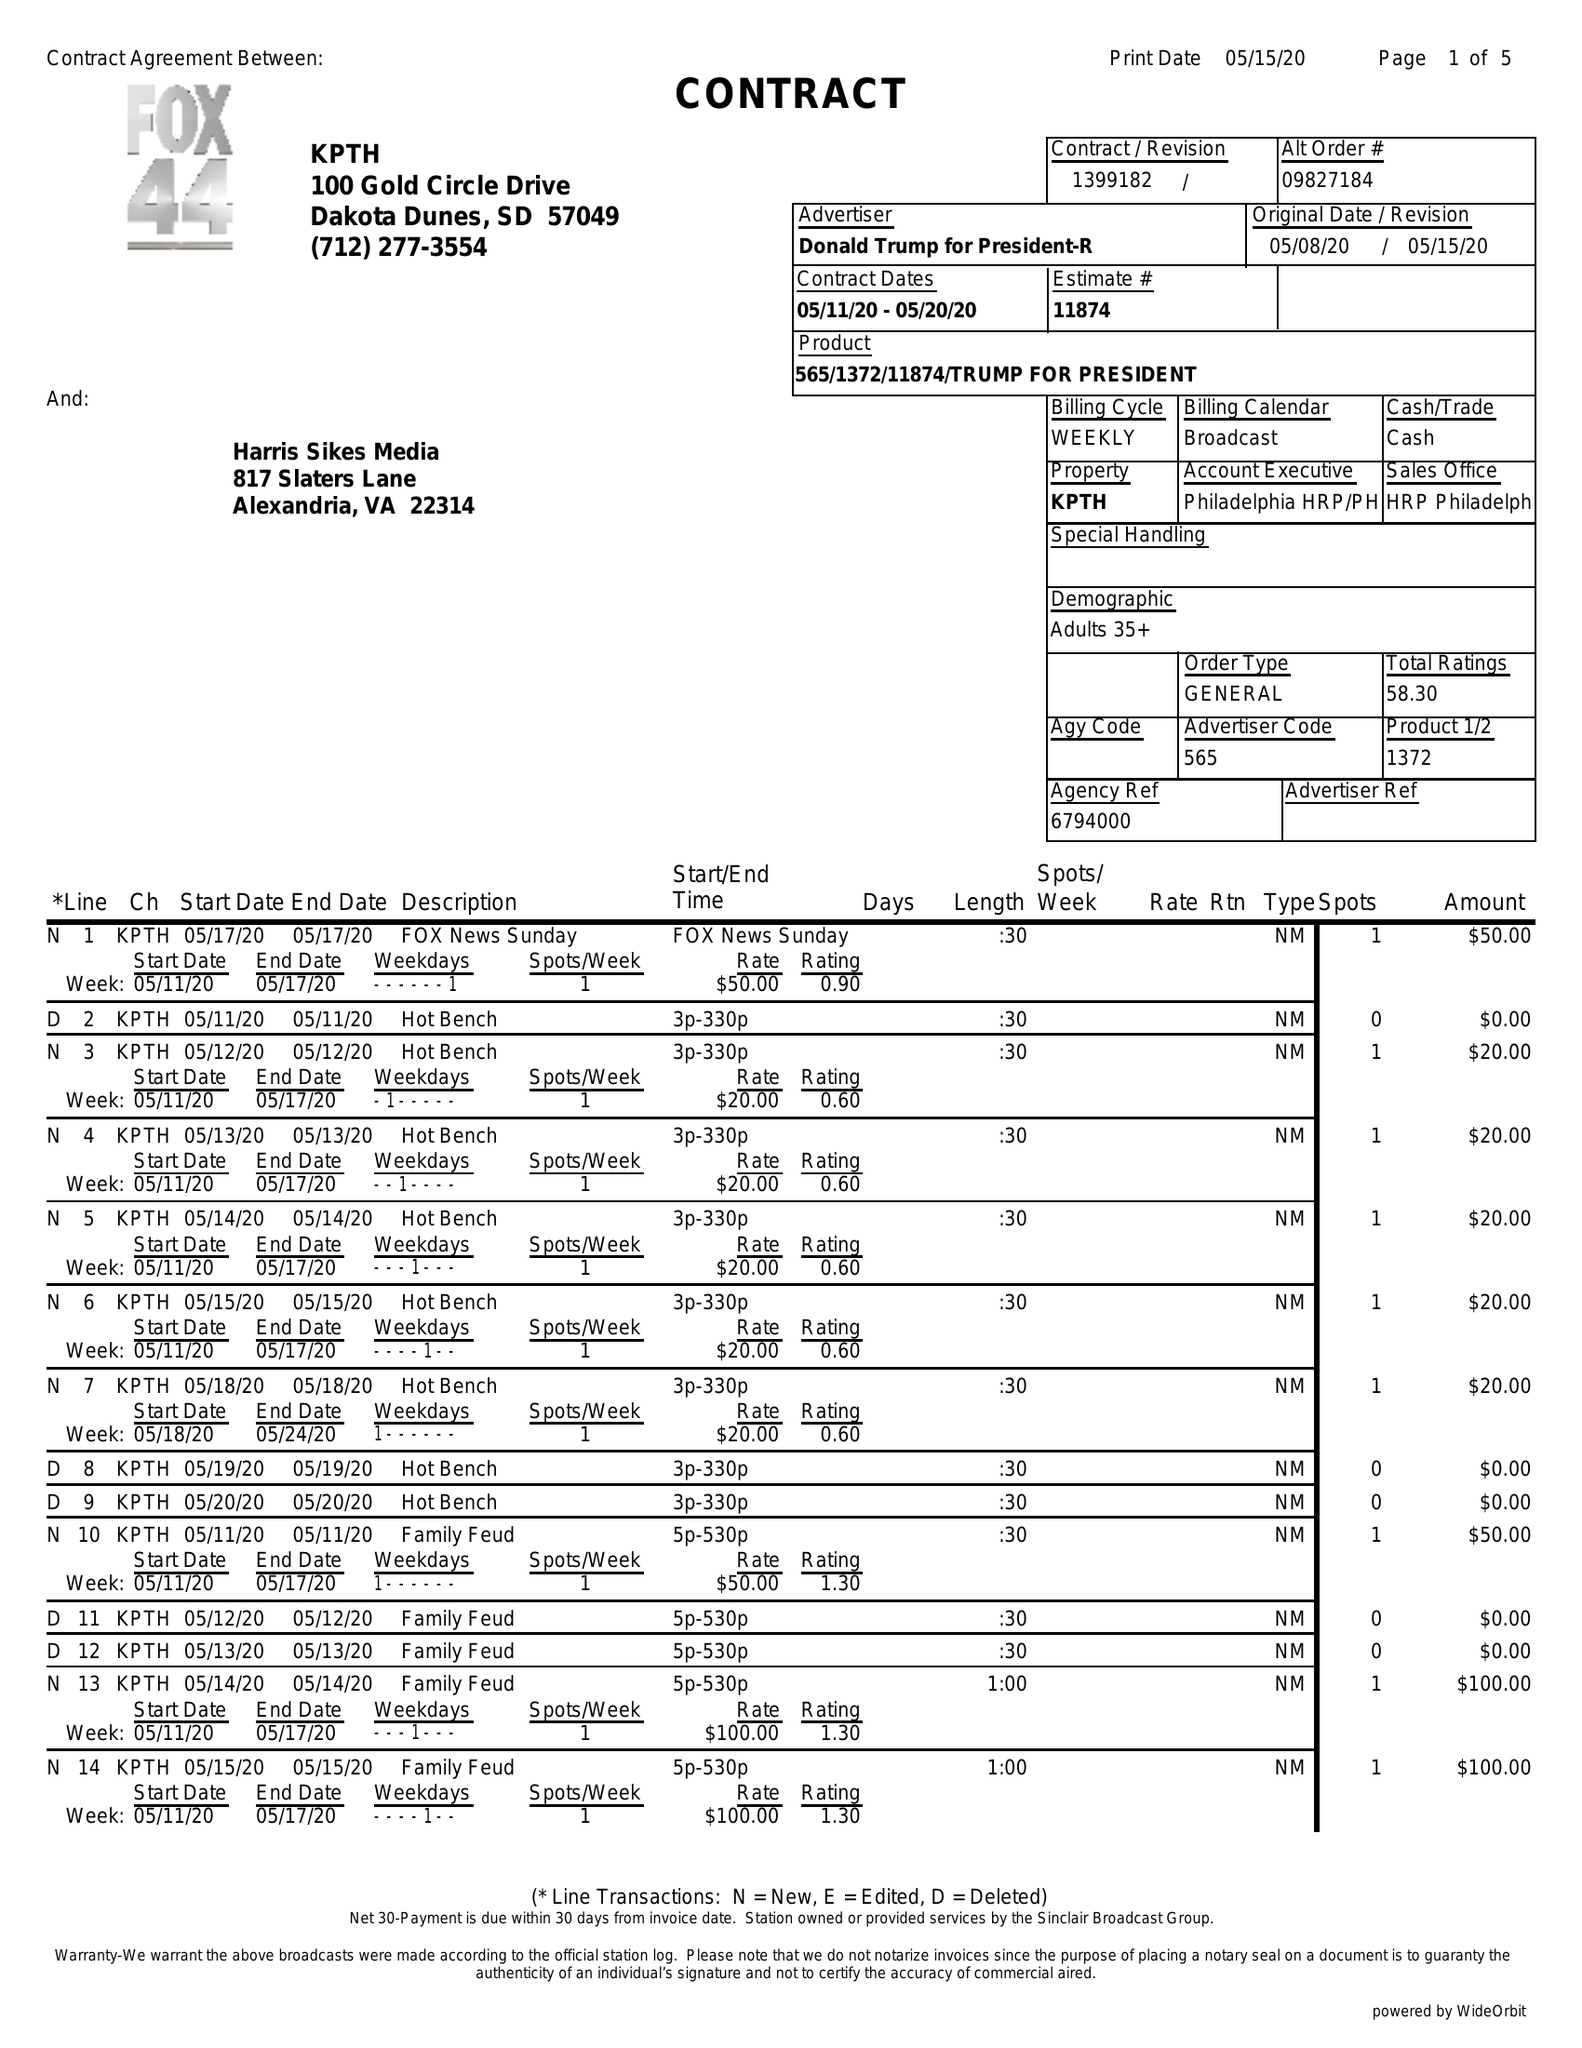What is the value for the flight_from?
Answer the question using a single word or phrase. 05/11/20 